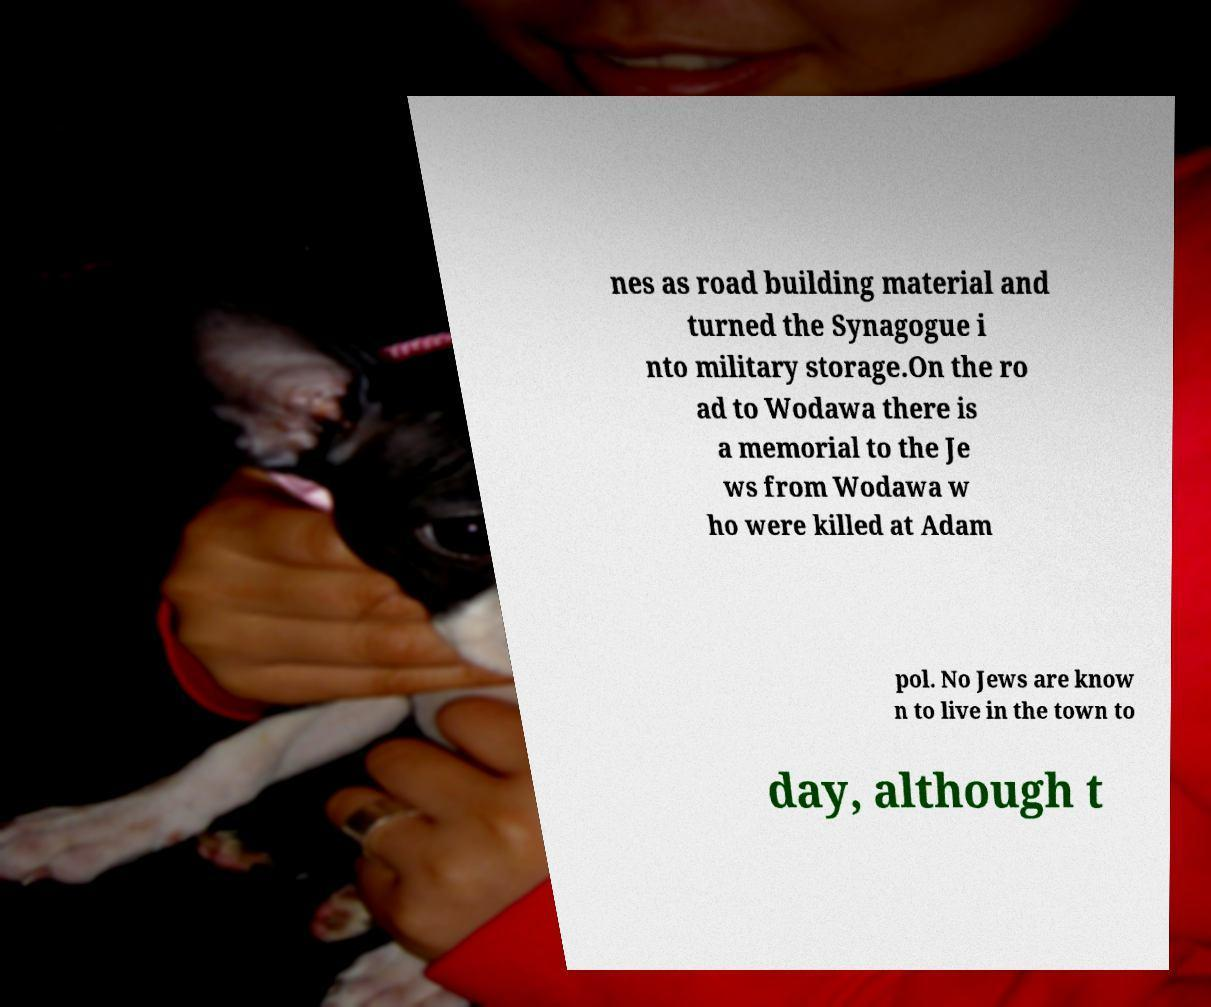There's text embedded in this image that I need extracted. Can you transcribe it verbatim? nes as road building material and turned the Synagogue i nto military storage.On the ro ad to Wodawa there is a memorial to the Je ws from Wodawa w ho were killed at Adam pol. No Jews are know n to live in the town to day, although t 